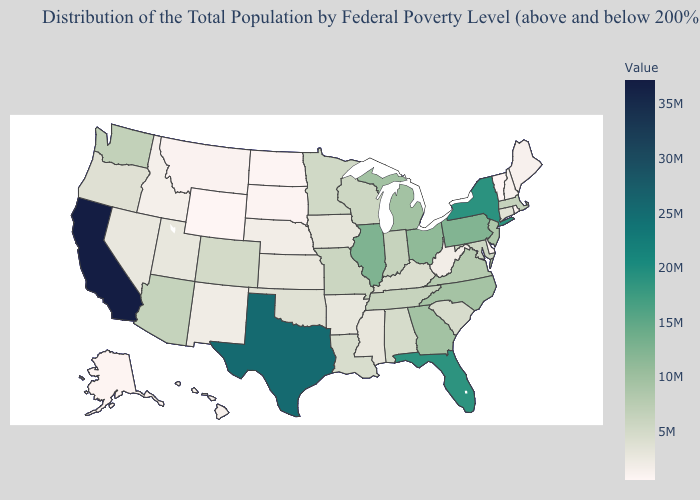Does Montana have a higher value than Minnesota?
Be succinct. No. Is the legend a continuous bar?
Keep it brief. Yes. Is the legend a continuous bar?
Concise answer only. Yes. Does Pennsylvania have a lower value than Texas?
Concise answer only. Yes. Is the legend a continuous bar?
Give a very brief answer. Yes. Which states have the lowest value in the USA?
Be succinct. Wyoming. 